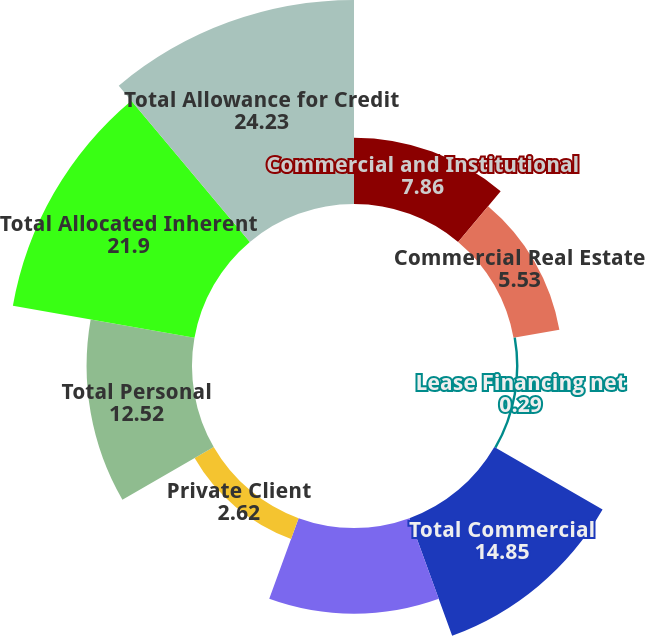Convert chart. <chart><loc_0><loc_0><loc_500><loc_500><pie_chart><fcel>Commercial and Institutional<fcel>Commercial Real Estate<fcel>Lease Financing net<fcel>Total Commercial<fcel>Residential Real Estate<fcel>Private Client<fcel>Total Personal<fcel>Total Allocated Inherent<fcel>Total Allowance for Credit<nl><fcel>7.86%<fcel>5.53%<fcel>0.29%<fcel>14.85%<fcel>10.19%<fcel>2.62%<fcel>12.52%<fcel>21.9%<fcel>24.23%<nl></chart> 